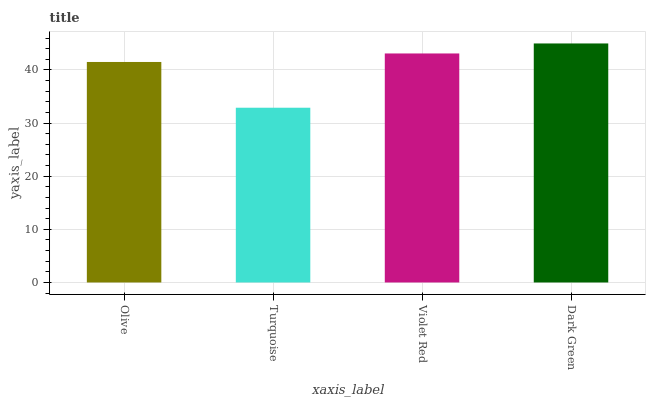Is Turquoise the minimum?
Answer yes or no. Yes. Is Dark Green the maximum?
Answer yes or no. Yes. Is Violet Red the minimum?
Answer yes or no. No. Is Violet Red the maximum?
Answer yes or no. No. Is Violet Red greater than Turquoise?
Answer yes or no. Yes. Is Turquoise less than Violet Red?
Answer yes or no. Yes. Is Turquoise greater than Violet Red?
Answer yes or no. No. Is Violet Red less than Turquoise?
Answer yes or no. No. Is Violet Red the high median?
Answer yes or no. Yes. Is Olive the low median?
Answer yes or no. Yes. Is Dark Green the high median?
Answer yes or no. No. Is Violet Red the low median?
Answer yes or no. No. 